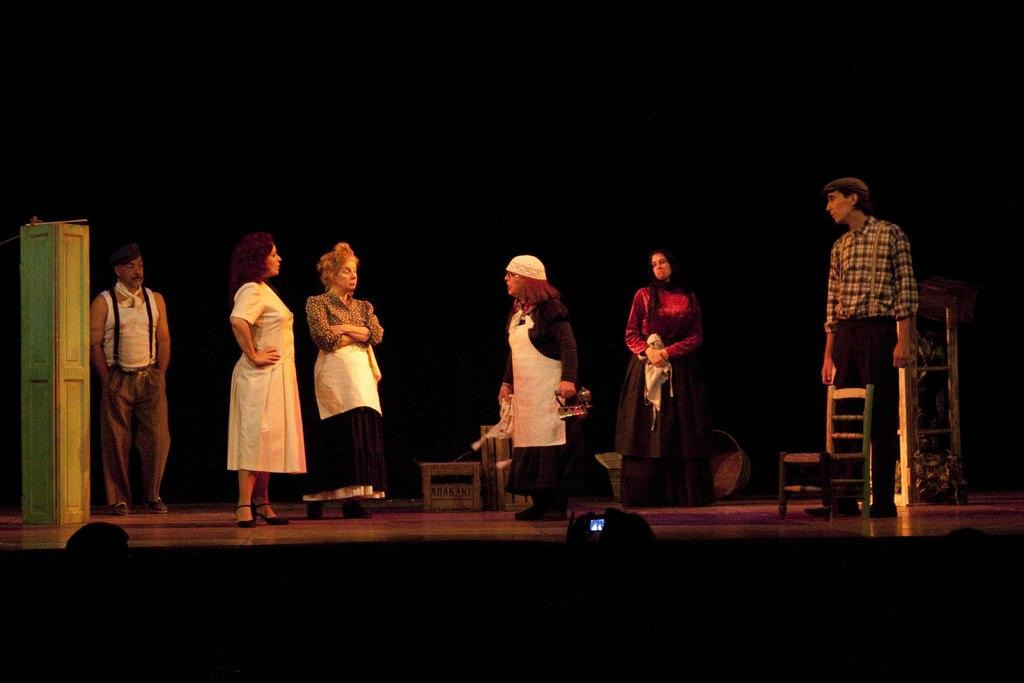How many people are present in the image? There are six people in the image. Where are the people located in the image? The people are standing on a stage. What are the people doing in the image? The people are performing a drama. What type of wool is being used as a prop in the drama? There is no wool visible in the image, and it is not mentioned that wool is being used as a prop in the drama. 